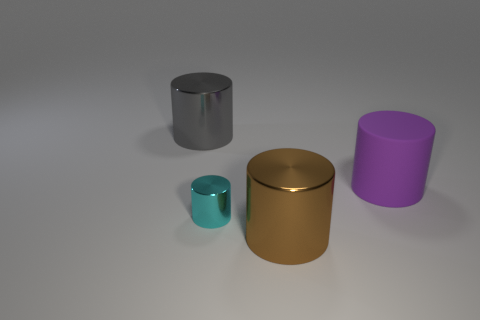What number of objects are gray cylinders or small objects?
Ensure brevity in your answer.  2. What size is the cylinder that is behind the big object that is right of the object that is in front of the small cylinder?
Give a very brief answer. Large. What number of other rubber objects are the same color as the rubber thing?
Your answer should be compact. 0. How many large brown cylinders are the same material as the purple cylinder?
Keep it short and to the point. 0. What number of objects are either big purple things or metallic cylinders in front of the gray cylinder?
Make the answer very short. 3. There is a big object left of the big shiny cylinder in front of the big object that is left of the cyan object; what color is it?
Provide a short and direct response. Gray. There is a cylinder that is to the right of the brown thing; what is its size?
Ensure brevity in your answer.  Large. How many tiny things are red metal spheres or brown cylinders?
Provide a succinct answer. 0. There is a object that is both in front of the large purple object and right of the small cyan cylinder; what is its color?
Provide a succinct answer. Brown. Are there any large purple rubber objects that have the same shape as the cyan metallic object?
Your response must be concise. Yes. 